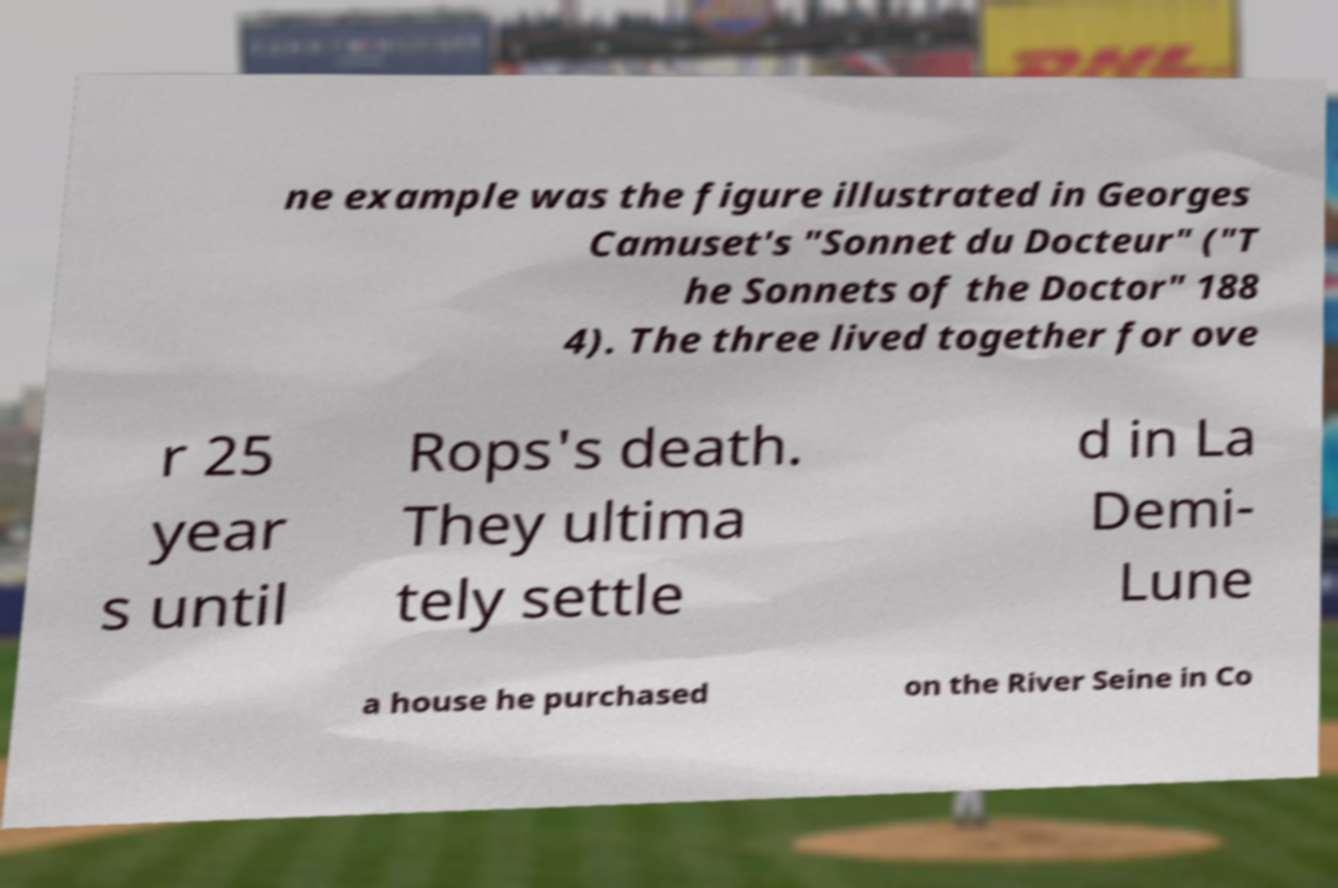Could you assist in decoding the text presented in this image and type it out clearly? ne example was the figure illustrated in Georges Camuset's "Sonnet du Docteur" ("T he Sonnets of the Doctor" 188 4). The three lived together for ove r 25 year s until Rops's death. They ultima tely settle d in La Demi- Lune a house he purchased on the River Seine in Co 